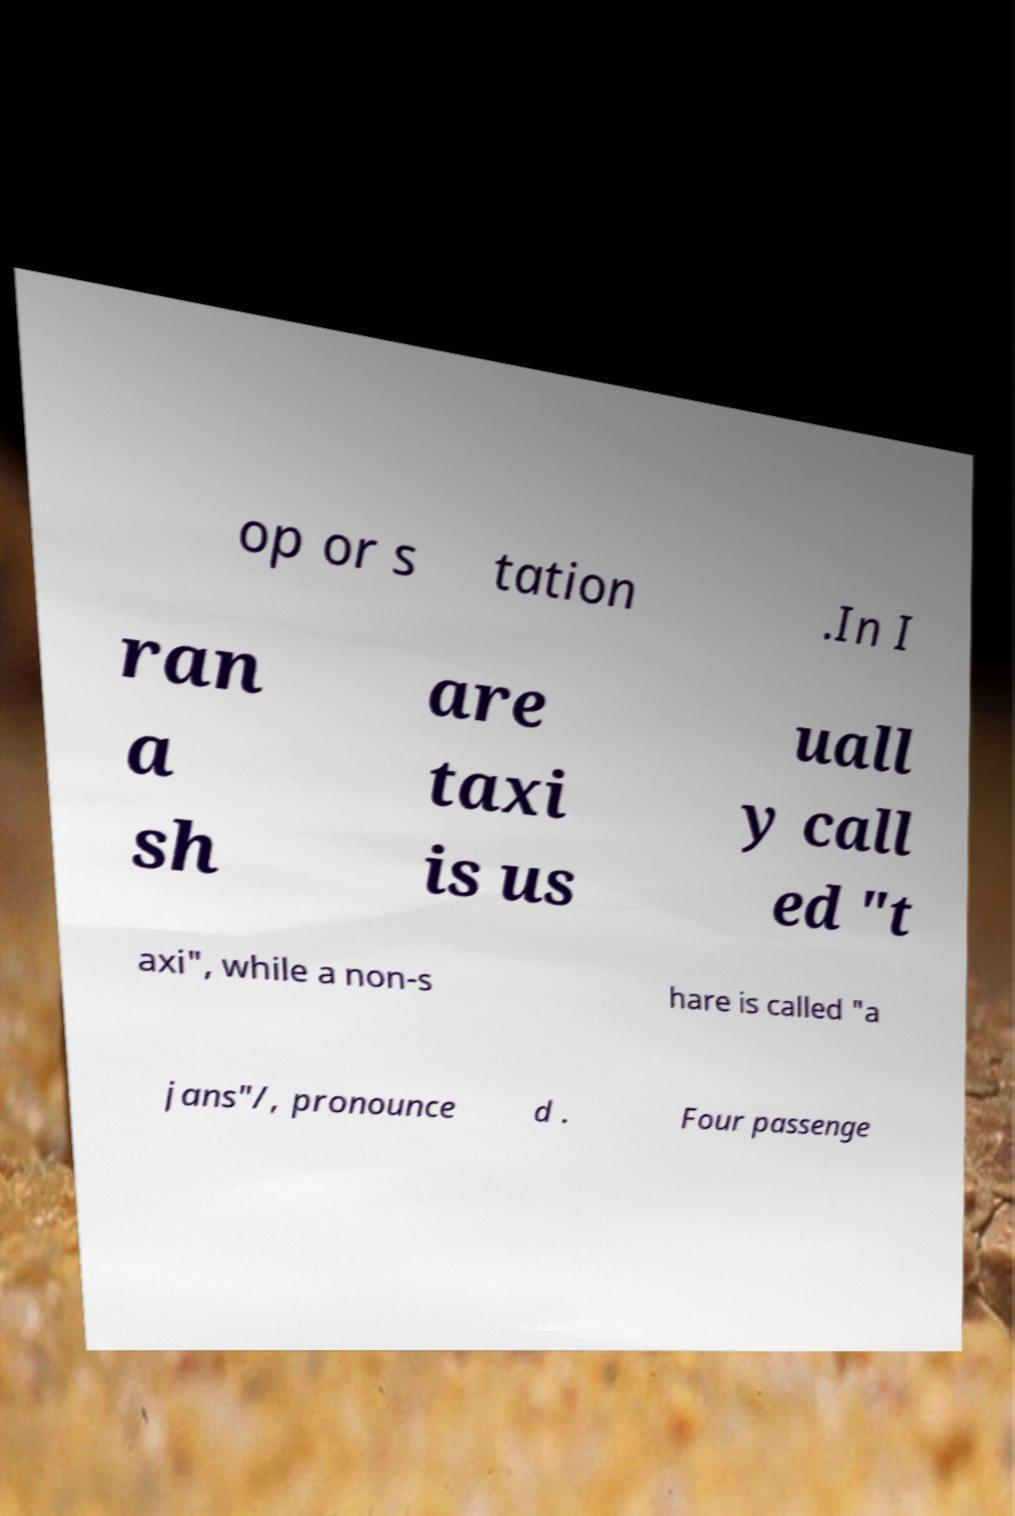I need the written content from this picture converted into text. Can you do that? op or s tation .In I ran a sh are taxi is us uall y call ed "t axi", while a non-s hare is called "a jans"/, pronounce d . Four passenge 